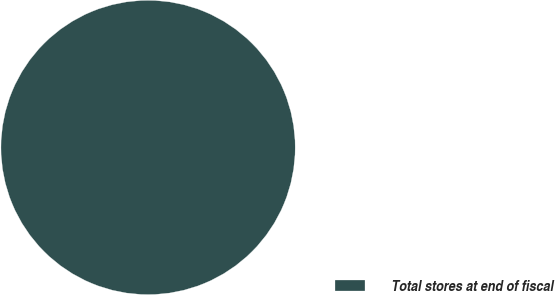Convert chart. <chart><loc_0><loc_0><loc_500><loc_500><pie_chart><fcel>Total stores at end of fiscal<nl><fcel>100.0%<nl></chart> 